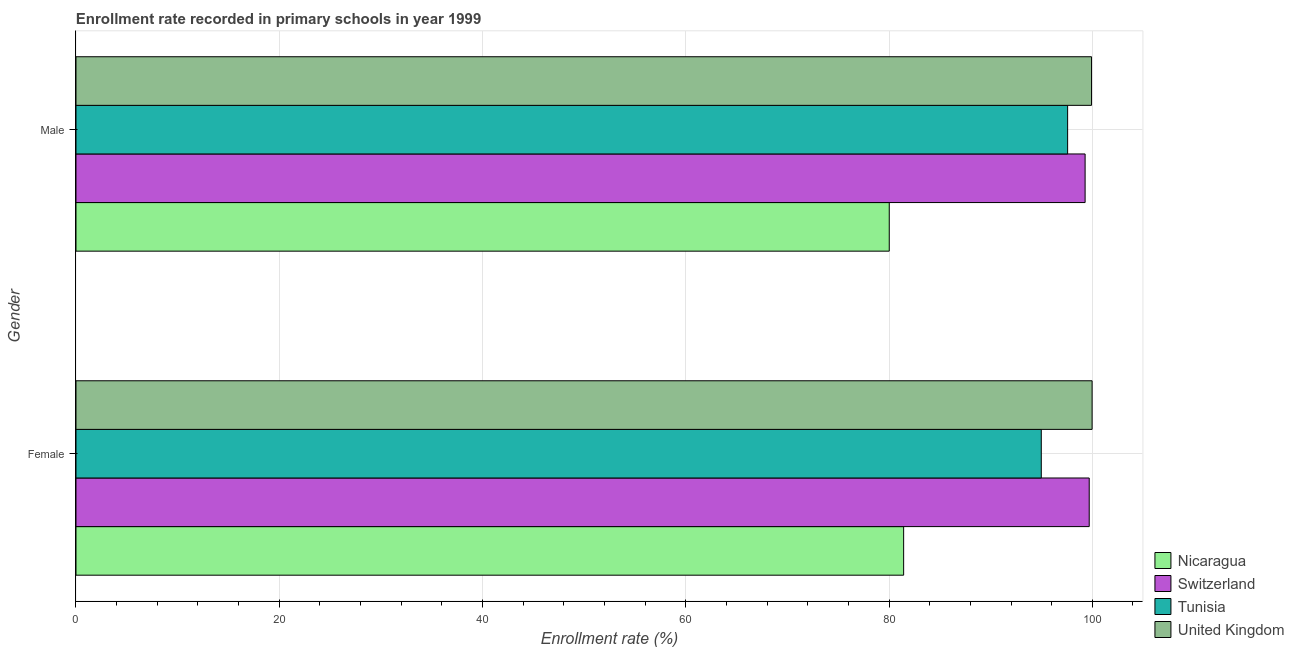How many groups of bars are there?
Provide a succinct answer. 2. How many bars are there on the 2nd tick from the bottom?
Your answer should be compact. 4. What is the label of the 2nd group of bars from the top?
Provide a succinct answer. Female. What is the enrollment rate of female students in Switzerland?
Offer a very short reply. 99.69. Across all countries, what is the maximum enrollment rate of male students?
Your response must be concise. 99.92. Across all countries, what is the minimum enrollment rate of male students?
Offer a terse response. 80.02. In which country was the enrollment rate of male students minimum?
Offer a terse response. Nicaragua. What is the total enrollment rate of female students in the graph?
Offer a terse response. 376.08. What is the difference between the enrollment rate of female students in Tunisia and that in Switzerland?
Provide a succinct answer. -4.72. What is the difference between the enrollment rate of male students in Switzerland and the enrollment rate of female students in Tunisia?
Give a very brief answer. 4.31. What is the average enrollment rate of female students per country?
Offer a terse response. 94.02. What is the difference between the enrollment rate of female students and enrollment rate of male students in United Kingdom?
Your answer should be compact. 0.06. What is the ratio of the enrollment rate of male students in Switzerland to that in Tunisia?
Keep it short and to the point. 1.02. What does the 1st bar from the top in Female represents?
Your response must be concise. United Kingdom. What does the 3rd bar from the bottom in Male represents?
Your answer should be very brief. Tunisia. How many bars are there?
Your answer should be compact. 8. Are all the bars in the graph horizontal?
Keep it short and to the point. Yes. How many countries are there in the graph?
Provide a short and direct response. 4. What is the difference between two consecutive major ticks on the X-axis?
Provide a succinct answer. 20. Are the values on the major ticks of X-axis written in scientific E-notation?
Your answer should be compact. No. Does the graph contain grids?
Offer a terse response. Yes. Where does the legend appear in the graph?
Keep it short and to the point. Bottom right. How many legend labels are there?
Offer a terse response. 4. How are the legend labels stacked?
Your answer should be compact. Vertical. What is the title of the graph?
Your answer should be compact. Enrollment rate recorded in primary schools in year 1999. What is the label or title of the X-axis?
Your answer should be compact. Enrollment rate (%). What is the label or title of the Y-axis?
Provide a succinct answer. Gender. What is the Enrollment rate (%) in Nicaragua in Female?
Keep it short and to the point. 81.43. What is the Enrollment rate (%) in Switzerland in Female?
Your answer should be very brief. 99.69. What is the Enrollment rate (%) in Tunisia in Female?
Your response must be concise. 94.98. What is the Enrollment rate (%) of United Kingdom in Female?
Make the answer very short. 99.98. What is the Enrollment rate (%) of Nicaragua in Male?
Provide a short and direct response. 80.02. What is the Enrollment rate (%) in Switzerland in Male?
Offer a terse response. 99.29. What is the Enrollment rate (%) in Tunisia in Male?
Provide a succinct answer. 97.57. What is the Enrollment rate (%) in United Kingdom in Male?
Ensure brevity in your answer.  99.92. Across all Gender, what is the maximum Enrollment rate (%) of Nicaragua?
Offer a very short reply. 81.43. Across all Gender, what is the maximum Enrollment rate (%) of Switzerland?
Offer a very short reply. 99.69. Across all Gender, what is the maximum Enrollment rate (%) of Tunisia?
Your response must be concise. 97.57. Across all Gender, what is the maximum Enrollment rate (%) of United Kingdom?
Your answer should be compact. 99.98. Across all Gender, what is the minimum Enrollment rate (%) in Nicaragua?
Offer a terse response. 80.02. Across all Gender, what is the minimum Enrollment rate (%) in Switzerland?
Provide a succinct answer. 99.29. Across all Gender, what is the minimum Enrollment rate (%) of Tunisia?
Make the answer very short. 94.98. Across all Gender, what is the minimum Enrollment rate (%) of United Kingdom?
Your answer should be compact. 99.92. What is the total Enrollment rate (%) of Nicaragua in the graph?
Offer a very short reply. 161.45. What is the total Enrollment rate (%) in Switzerland in the graph?
Ensure brevity in your answer.  198.98. What is the total Enrollment rate (%) of Tunisia in the graph?
Offer a very short reply. 192.55. What is the total Enrollment rate (%) in United Kingdom in the graph?
Give a very brief answer. 199.9. What is the difference between the Enrollment rate (%) in Nicaragua in Female and that in Male?
Provide a succinct answer. 1.42. What is the difference between the Enrollment rate (%) of Switzerland in Female and that in Male?
Your answer should be compact. 0.4. What is the difference between the Enrollment rate (%) in Tunisia in Female and that in Male?
Offer a terse response. -2.59. What is the difference between the Enrollment rate (%) of United Kingdom in Female and that in Male?
Offer a very short reply. 0.06. What is the difference between the Enrollment rate (%) in Nicaragua in Female and the Enrollment rate (%) in Switzerland in Male?
Keep it short and to the point. -17.86. What is the difference between the Enrollment rate (%) of Nicaragua in Female and the Enrollment rate (%) of Tunisia in Male?
Provide a short and direct response. -16.14. What is the difference between the Enrollment rate (%) of Nicaragua in Female and the Enrollment rate (%) of United Kingdom in Male?
Provide a succinct answer. -18.49. What is the difference between the Enrollment rate (%) of Switzerland in Female and the Enrollment rate (%) of Tunisia in Male?
Offer a very short reply. 2.12. What is the difference between the Enrollment rate (%) in Switzerland in Female and the Enrollment rate (%) in United Kingdom in Male?
Your answer should be very brief. -0.23. What is the difference between the Enrollment rate (%) in Tunisia in Female and the Enrollment rate (%) in United Kingdom in Male?
Provide a succinct answer. -4.94. What is the average Enrollment rate (%) of Nicaragua per Gender?
Keep it short and to the point. 80.73. What is the average Enrollment rate (%) in Switzerland per Gender?
Provide a short and direct response. 99.49. What is the average Enrollment rate (%) in Tunisia per Gender?
Your response must be concise. 96.27. What is the average Enrollment rate (%) of United Kingdom per Gender?
Offer a terse response. 99.95. What is the difference between the Enrollment rate (%) in Nicaragua and Enrollment rate (%) in Switzerland in Female?
Offer a terse response. -18.26. What is the difference between the Enrollment rate (%) of Nicaragua and Enrollment rate (%) of Tunisia in Female?
Your answer should be compact. -13.54. What is the difference between the Enrollment rate (%) in Nicaragua and Enrollment rate (%) in United Kingdom in Female?
Ensure brevity in your answer.  -18.54. What is the difference between the Enrollment rate (%) in Switzerland and Enrollment rate (%) in Tunisia in Female?
Your answer should be very brief. 4.72. What is the difference between the Enrollment rate (%) of Switzerland and Enrollment rate (%) of United Kingdom in Female?
Make the answer very short. -0.28. What is the difference between the Enrollment rate (%) of Tunisia and Enrollment rate (%) of United Kingdom in Female?
Provide a succinct answer. -5. What is the difference between the Enrollment rate (%) in Nicaragua and Enrollment rate (%) in Switzerland in Male?
Offer a very short reply. -19.27. What is the difference between the Enrollment rate (%) of Nicaragua and Enrollment rate (%) of Tunisia in Male?
Offer a terse response. -17.55. What is the difference between the Enrollment rate (%) of Nicaragua and Enrollment rate (%) of United Kingdom in Male?
Ensure brevity in your answer.  -19.9. What is the difference between the Enrollment rate (%) of Switzerland and Enrollment rate (%) of Tunisia in Male?
Offer a very short reply. 1.72. What is the difference between the Enrollment rate (%) of Switzerland and Enrollment rate (%) of United Kingdom in Male?
Keep it short and to the point. -0.63. What is the difference between the Enrollment rate (%) of Tunisia and Enrollment rate (%) of United Kingdom in Male?
Provide a succinct answer. -2.35. What is the ratio of the Enrollment rate (%) of Nicaragua in Female to that in Male?
Make the answer very short. 1.02. What is the ratio of the Enrollment rate (%) of Switzerland in Female to that in Male?
Offer a very short reply. 1. What is the ratio of the Enrollment rate (%) of Tunisia in Female to that in Male?
Ensure brevity in your answer.  0.97. What is the difference between the highest and the second highest Enrollment rate (%) of Nicaragua?
Your answer should be very brief. 1.42. What is the difference between the highest and the second highest Enrollment rate (%) of Switzerland?
Give a very brief answer. 0.4. What is the difference between the highest and the second highest Enrollment rate (%) in Tunisia?
Make the answer very short. 2.59. What is the difference between the highest and the second highest Enrollment rate (%) in United Kingdom?
Provide a succinct answer. 0.06. What is the difference between the highest and the lowest Enrollment rate (%) in Nicaragua?
Your answer should be compact. 1.42. What is the difference between the highest and the lowest Enrollment rate (%) in Switzerland?
Your response must be concise. 0.4. What is the difference between the highest and the lowest Enrollment rate (%) of Tunisia?
Give a very brief answer. 2.59. What is the difference between the highest and the lowest Enrollment rate (%) in United Kingdom?
Provide a short and direct response. 0.06. 